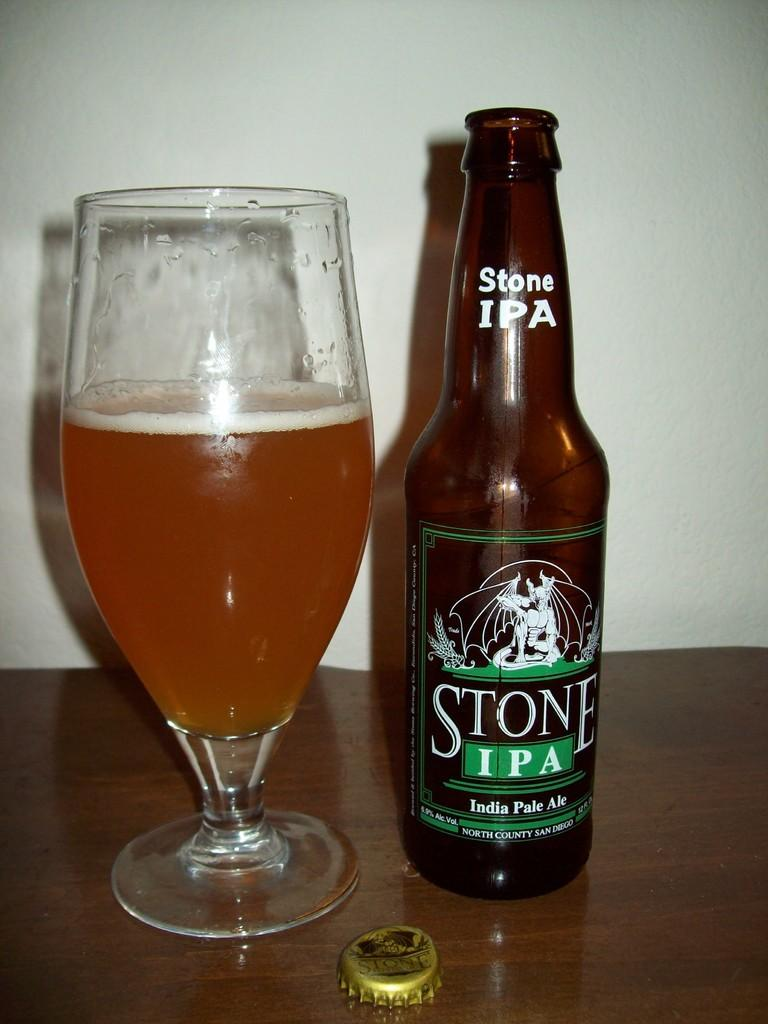<image>
Relay a brief, clear account of the picture shown. Beer bottle of Stone IPA next to a cup of beer. 